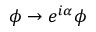Convert formula to latex. <formula><loc_0><loc_0><loc_500><loc_500>\phi \rightarrow e ^ { i \alpha } \phi</formula> 